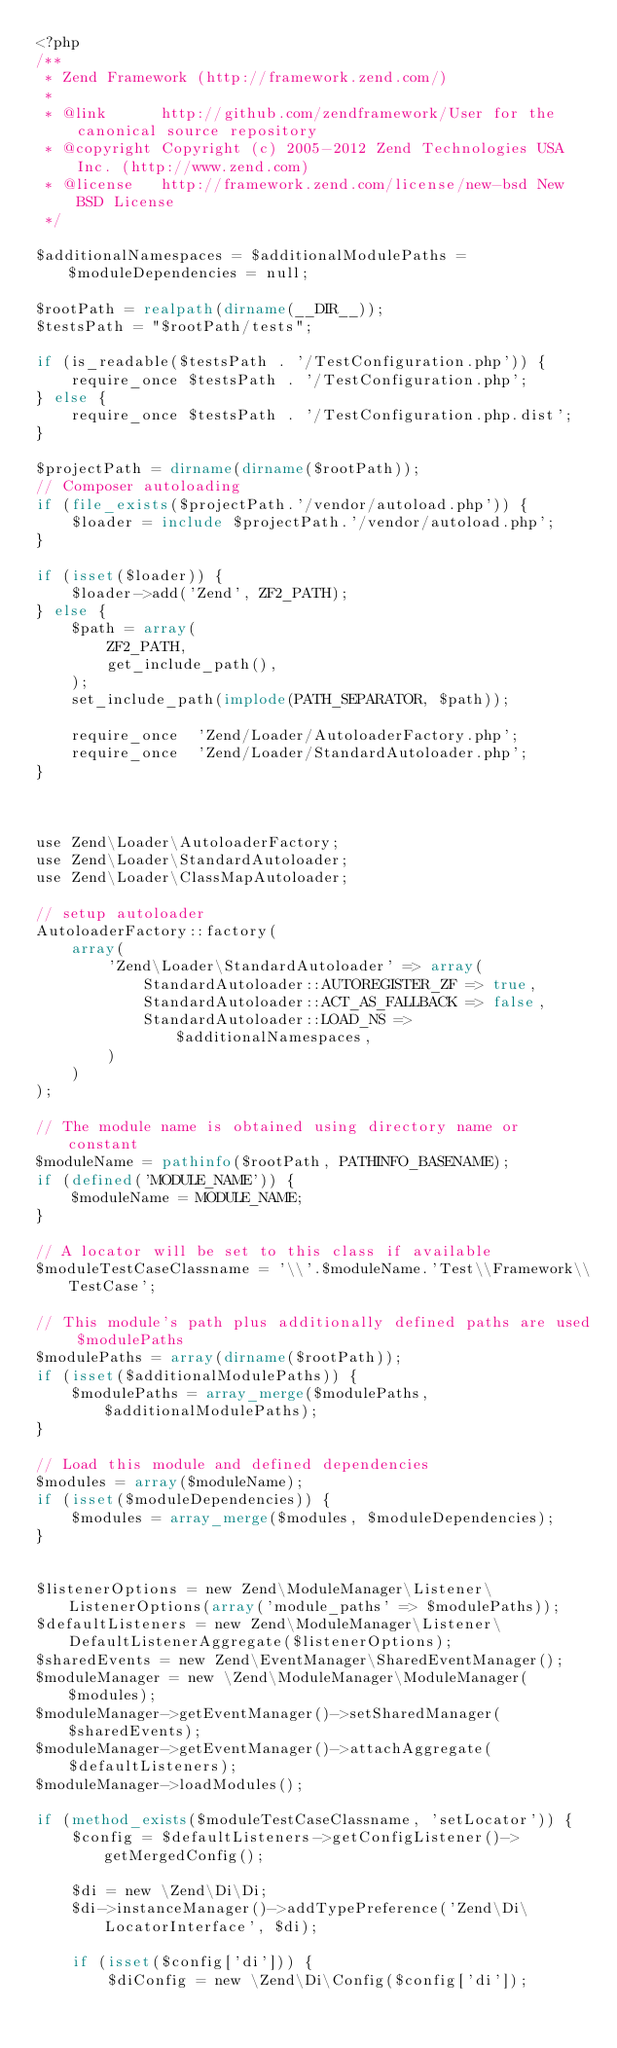<code> <loc_0><loc_0><loc_500><loc_500><_PHP_><?php
/**
 * Zend Framework (http://framework.zend.com/)
 *
 * @link      http://github.com/zendframework/User for the canonical source repository
 * @copyright Copyright (c) 2005-2012 Zend Technologies USA Inc. (http://www.zend.com)
 * @license   http://framework.zend.com/license/new-bsd New BSD License
 */

$additionalNamespaces = $additionalModulePaths = $moduleDependencies = null;

$rootPath = realpath(dirname(__DIR__));
$testsPath = "$rootPath/tests";

if (is_readable($testsPath . '/TestConfiguration.php')) {
    require_once $testsPath . '/TestConfiguration.php';
} else {
    require_once $testsPath . '/TestConfiguration.php.dist';
}

$projectPath = dirname(dirname($rootPath));
// Composer autoloading
if (file_exists($projectPath.'/vendor/autoload.php')) {
    $loader = include $projectPath.'/vendor/autoload.php';
}

if (isset($loader)) {
    $loader->add('Zend', ZF2_PATH);
} else {
    $path = array(
        ZF2_PATH,
        get_include_path(),
    );
    set_include_path(implode(PATH_SEPARATOR, $path));

    require_once  'Zend/Loader/AutoloaderFactory.php';
    require_once  'Zend/Loader/StandardAutoloader.php';
}



use Zend\Loader\AutoloaderFactory;
use Zend\Loader\StandardAutoloader;
use Zend\Loader\ClassMapAutoloader;

// setup autoloader
AutoloaderFactory::factory(
    array(
        'Zend\Loader\StandardAutoloader' => array(
            StandardAutoloader::AUTOREGISTER_ZF => true,
            StandardAutoloader::ACT_AS_FALLBACK => false,
            StandardAutoloader::LOAD_NS => $additionalNamespaces,
        )
    )
);

// The module name is obtained using directory name or constant
$moduleName = pathinfo($rootPath, PATHINFO_BASENAME);
if (defined('MODULE_NAME')) {
    $moduleName = MODULE_NAME;
}

// A locator will be set to this class if available
$moduleTestCaseClassname = '\\'.$moduleName.'Test\\Framework\\TestCase';

// This module's path plus additionally defined paths are used $modulePaths
$modulePaths = array(dirname($rootPath));
if (isset($additionalModulePaths)) {
    $modulePaths = array_merge($modulePaths, $additionalModulePaths);
}

// Load this module and defined dependencies
$modules = array($moduleName);
if (isset($moduleDependencies)) {
    $modules = array_merge($modules, $moduleDependencies);
}


$listenerOptions = new Zend\ModuleManager\Listener\ListenerOptions(array('module_paths' => $modulePaths));
$defaultListeners = new Zend\ModuleManager\Listener\DefaultListenerAggregate($listenerOptions);
$sharedEvents = new Zend\EventManager\SharedEventManager();
$moduleManager = new \Zend\ModuleManager\ModuleManager($modules);
$moduleManager->getEventManager()->setSharedManager($sharedEvents);
$moduleManager->getEventManager()->attachAggregate($defaultListeners);
$moduleManager->loadModules();

if (method_exists($moduleTestCaseClassname, 'setLocator')) {
    $config = $defaultListeners->getConfigListener()->getMergedConfig();

    $di = new \Zend\Di\Di;
    $di->instanceManager()->addTypePreference('Zend\Di\LocatorInterface', $di);

    if (isset($config['di'])) {
        $diConfig = new \Zend\Di\Config($config['di']);</code> 